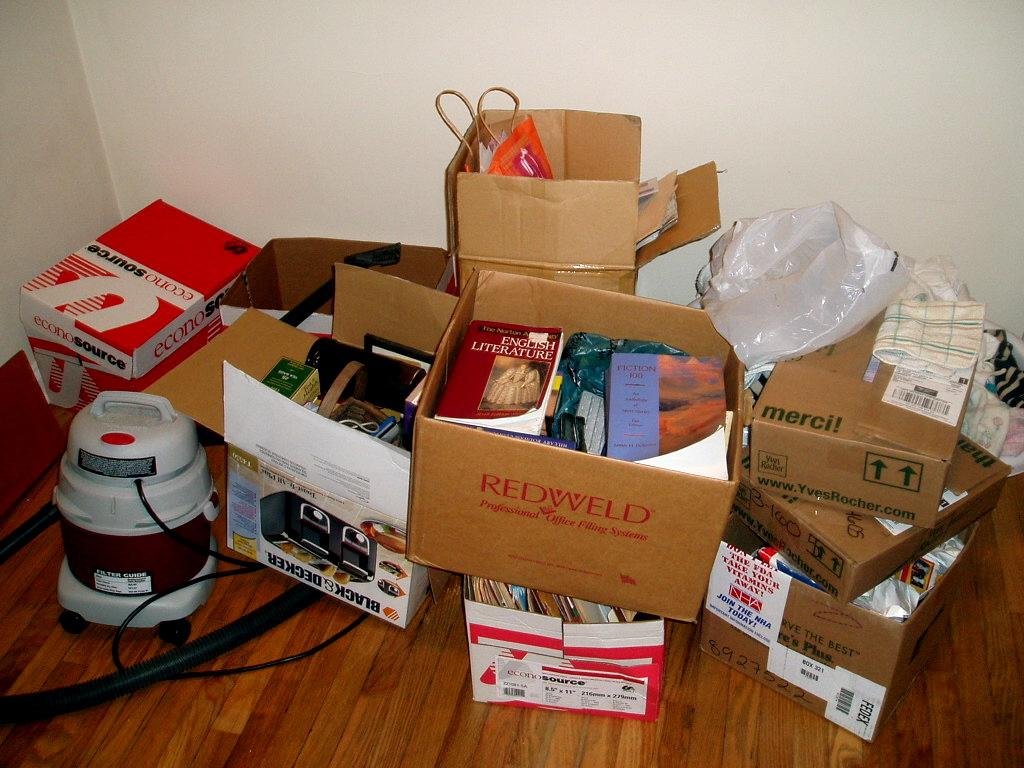<image>
Summarize the visual content of the image. the word red is on the front of a brown box 